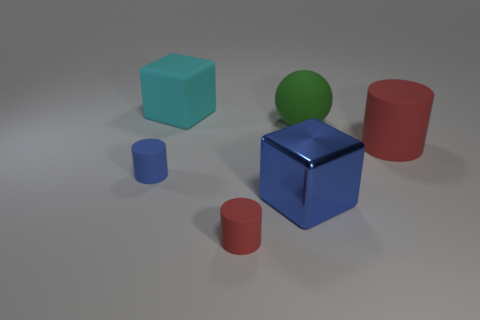The other shiny object that is the same shape as the big cyan thing is what size?
Your answer should be compact. Large. There is a thing that is the same size as the blue matte cylinder; what is it made of?
Ensure brevity in your answer.  Rubber. What number of other objects are the same color as the metallic object?
Your response must be concise. 1. The blue cylinder is what size?
Give a very brief answer. Small. Is the number of matte objects in front of the rubber ball greater than the number of green balls that are in front of the small red matte cylinder?
Keep it short and to the point. Yes. The large thing that is to the left of the green ball and in front of the big rubber ball is made of what material?
Make the answer very short. Metal. Is the shape of the big cyan rubber object the same as the large red thing?
Make the answer very short. No. Is there any other thing that has the same size as the green matte thing?
Keep it short and to the point. Yes. How many cylinders are left of the tiny red thing?
Your response must be concise. 1. Do the red rubber cylinder that is behind the blue matte cylinder and the big cyan matte block have the same size?
Provide a short and direct response. Yes. 